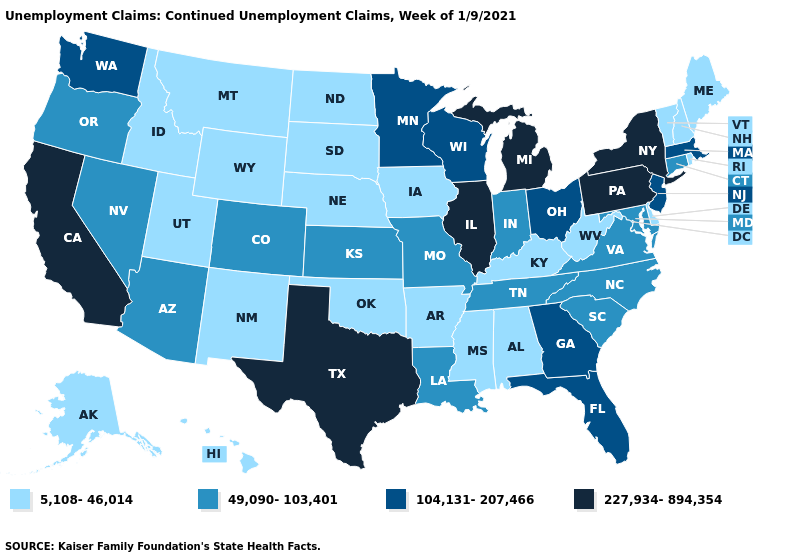Among the states that border Vermont , which have the lowest value?
Give a very brief answer. New Hampshire. Does North Dakota have the lowest value in the USA?
Short answer required. Yes. What is the value of Kansas?
Quick response, please. 49,090-103,401. Among the states that border South Dakota , which have the lowest value?
Give a very brief answer. Iowa, Montana, Nebraska, North Dakota, Wyoming. Does the first symbol in the legend represent the smallest category?
Write a very short answer. Yes. Which states hav the highest value in the MidWest?
Answer briefly. Illinois, Michigan. What is the value of Pennsylvania?
Write a very short answer. 227,934-894,354. What is the lowest value in the USA?
Keep it brief. 5,108-46,014. Name the states that have a value in the range 227,934-894,354?
Quick response, please. California, Illinois, Michigan, New York, Pennsylvania, Texas. What is the value of Texas?
Answer briefly. 227,934-894,354. Name the states that have a value in the range 49,090-103,401?
Be succinct. Arizona, Colorado, Connecticut, Indiana, Kansas, Louisiana, Maryland, Missouri, Nevada, North Carolina, Oregon, South Carolina, Tennessee, Virginia. Name the states that have a value in the range 49,090-103,401?
Quick response, please. Arizona, Colorado, Connecticut, Indiana, Kansas, Louisiana, Maryland, Missouri, Nevada, North Carolina, Oregon, South Carolina, Tennessee, Virginia. Does the first symbol in the legend represent the smallest category?
Write a very short answer. Yes. Does the first symbol in the legend represent the smallest category?
Quick response, please. Yes. Which states hav the highest value in the South?
Give a very brief answer. Texas. 